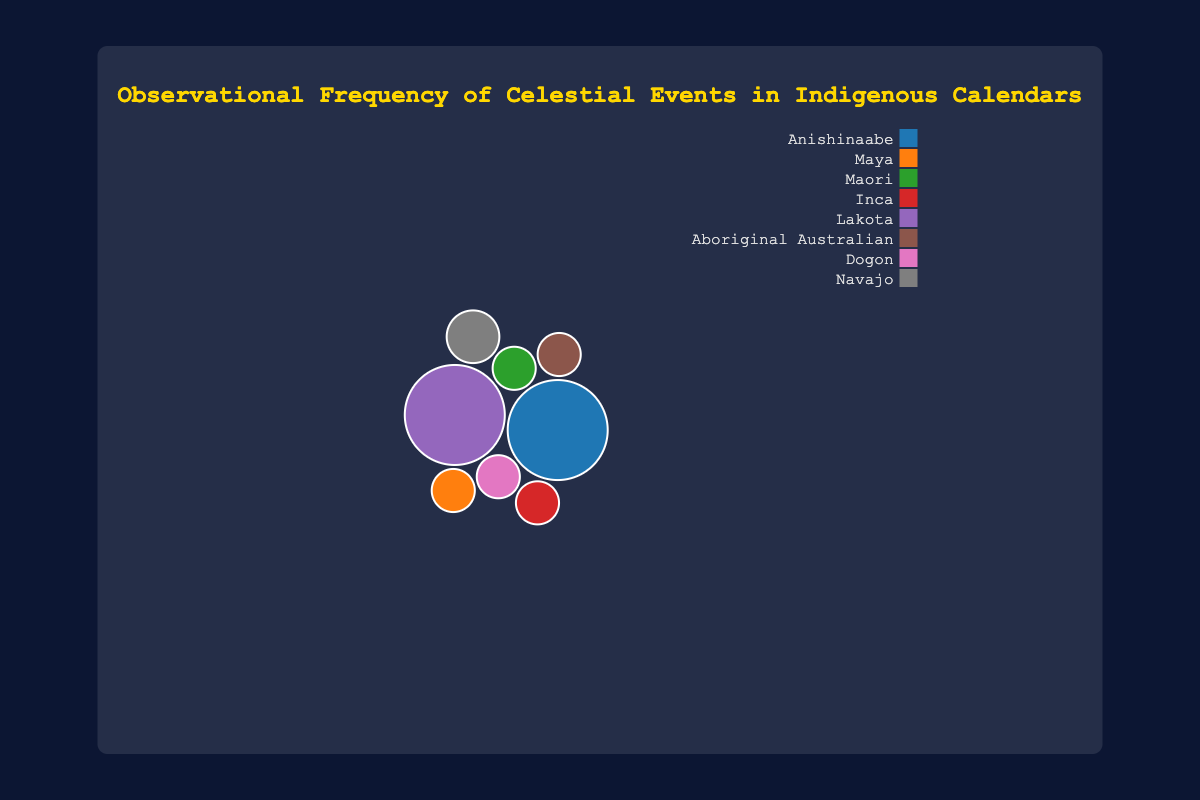Which celestial event has the highest frequency in the Anishinaabe calendar? Observing the bubbles, the 'Full Moon' event in the Anishinaabe calendar has a frequency of 12, which is the highest for this calendar.
Answer: Full Moon Which event in the Maya calendar has the highest importance? By inspecting the bubbles, the 'Winter Solstice' event in the Maya calendar has an importance value of 10.
Answer: Winter Solstice How does the frequency of the New Moon event in the Lakota calendar compare to the frequency of the Equinox event in the Navajo calendar? The New Moon event in the Lakota calendar occurs 12 times, while the Equinox event in the Navajo calendar occurs 2 times. Therefore, the New Moon event happens more frequently.
Answer: New Moon happens more frequently What is the overall average importance of the celestial events? Summing the importance values: 8 + 10 + 7 + 9 + 6 + 8 + 9 + 7 equals 64. Dividing by the number of events (8), the average importance is 64/8 = 8.
Answer: 8 Which indigenous calendar has the most diverse range of celestial events? The chart shows that each calendar is tied to different unique events, but by counting them, each calendar typically tracks one or two unique events. There isn't one with significantly more diversity.
Answer: No significant difference Comparing the importance levels, which celestial event ranks equally in importance in both the Anishinaabe and Aboriginal Australian calendars? Both the 'Full Moon' event in Anishinaabe and 'Orion's Belt' in the Aboriginal Australian calendar have an importance value of 8.
Answer: Full Moon and Orion's Belt Which celestial event is exclusively documented in the Dogon calendar, and what is its frequency? 'Sirius Rising' is the celestial event that appears in the Dogon calendar with a frequency of 1.
Answer: Sirius Rising, frequency 1 How many events in total have the highest importance value of 10? By counting the bubbles with an importance value of 10, only the 'Winter Solstice' event in the Maya calendar qualifies.
Answer: 1 What color represents the Anishinaabe calendar in the bubble chart? The color of the bubbles varies by calendar, and each calendar is represented by a unique color. Cross-referencing the legend and bubble color will show the specific color for Anishinaabe.
Answer: Depends on chart legend but specific to Anishinaabe calendar How many unique celestial events are tracked by all the indigenous calendars combined? Counting each unique event name listed: Full Moon, Winter Solstice, Pleiades Rising, Summer Solstice, New Moon, Orion's Belt, Sirius Rising, Equinox – gives a total of 8 unique events.
Answer: 8 